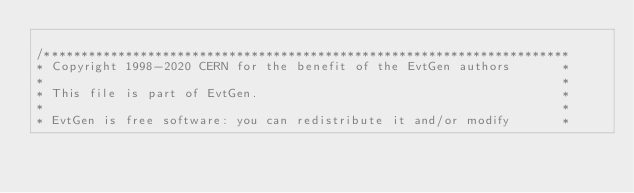<code> <loc_0><loc_0><loc_500><loc_500><_C++_>
/***********************************************************************
* Copyright 1998-2020 CERN for the benefit of the EvtGen authors       *
*                                                                      *
* This file is part of EvtGen.                                         *
*                                                                      *
* EvtGen is free software: you can redistribute it and/or modify       *</code> 